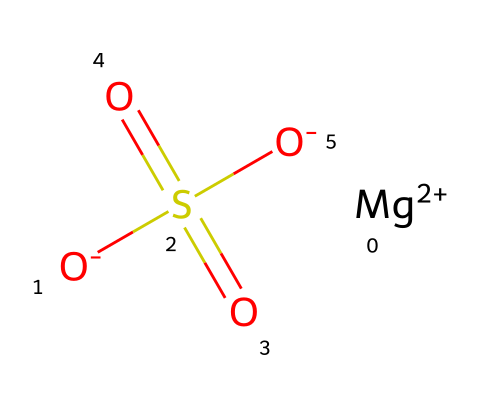What is the name of this chemical? The SMILES representation indicates the presence of magnesium, sulfate, and oxygen atoms, corresponding to magnesium sulfate.
Answer: magnesium sulfate How many oxygen atoms are present in this structure? By analyzing the SMILES, we can count the oxygen atoms: one in the sulfate group and two more from the two -O in the compound, totaling four.
Answer: four What is the charge of the magnesium atom in this chemical compound? The SMILES notation shows [Mg+2], indicating that the magnesium atom carries a +2 charge.
Answer: +2 How many sulfur atoms are in magnesium sulfate? The structure includes only one sulfur atom, identified in the sulfate group (S(=O)(=O)).
Answer: one Does magnesium sulfate dissociate into ions in water? Magnesium sulfate is an electrolyte, which means it dissociates into ions when dissolved in water, providing magnesium and sulfate ions.
Answer: yes What type of chemical is magnesium sulfate classified as? Given that it can dissociate into ions in solution and conduct electricity, magnesium sulfate is classified as an electrolyte.
Answer: electrolyte 